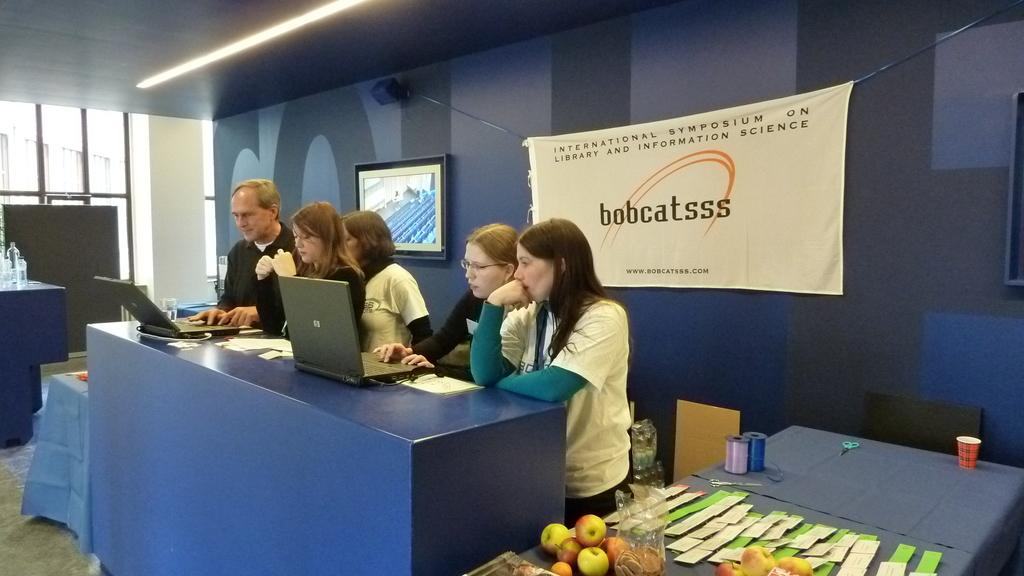How many people are in the image? There is a group of people in the image. What are the people doing in the image? The people are standing and using laptops on a table. What type of food can be seen in the image? There are fruits visible in the image. What is hanging on the wall in the background? There is a television on the wall. What can be seen in the background of the image? There is a banner in the background. What type of laborer is washing the floor in the image? There is no laborer washing the floor in the image; it only shows a group of people using laptops on a table. 